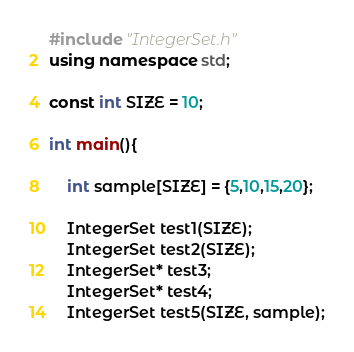Convert code to text. <code><loc_0><loc_0><loc_500><loc_500><_C++_>#include "IntegerSet.h"
using namespace std;

const int SIZE = 10;

int main(){

	int sample[SIZE] = {5,10,15,20};

	IntegerSet test1(SIZE);
	IntegerSet test2(SIZE);
	IntegerSet* test3;
	IntegerSet* test4;
	IntegerSet test5(SIZE, sample);
</code> 